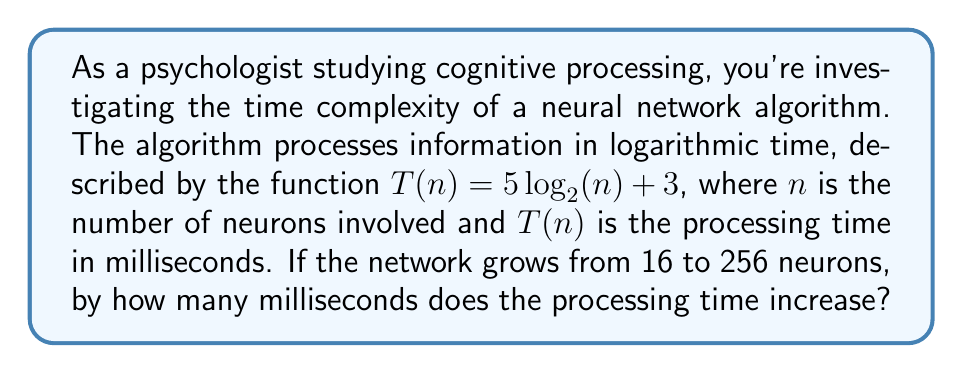Show me your answer to this math problem. To solve this problem, we'll follow these steps:

1) Calculate $T(16)$:
   $T(16) = 5\log_2(16) + 3$
   $= 5 \cdot 4 + 3$ (since $2^4 = 16$)
   $= 20 + 3 = 23$ ms

2) Calculate $T(256)$:
   $T(256) = 5\log_2(256) + 3$
   $= 5 \cdot 8 + 3$ (since $2^8 = 256$)
   $= 40 + 3 = 43$ ms

3) Calculate the difference:
   Increase in processing time = $T(256) - T(16)$
   $= 43 - 23 = 20$ ms

This result aligns with cognitive science principles, demonstrating how information processing speed scales logarithmically with increased complexity, rather than linearly.
Answer: 20 ms 